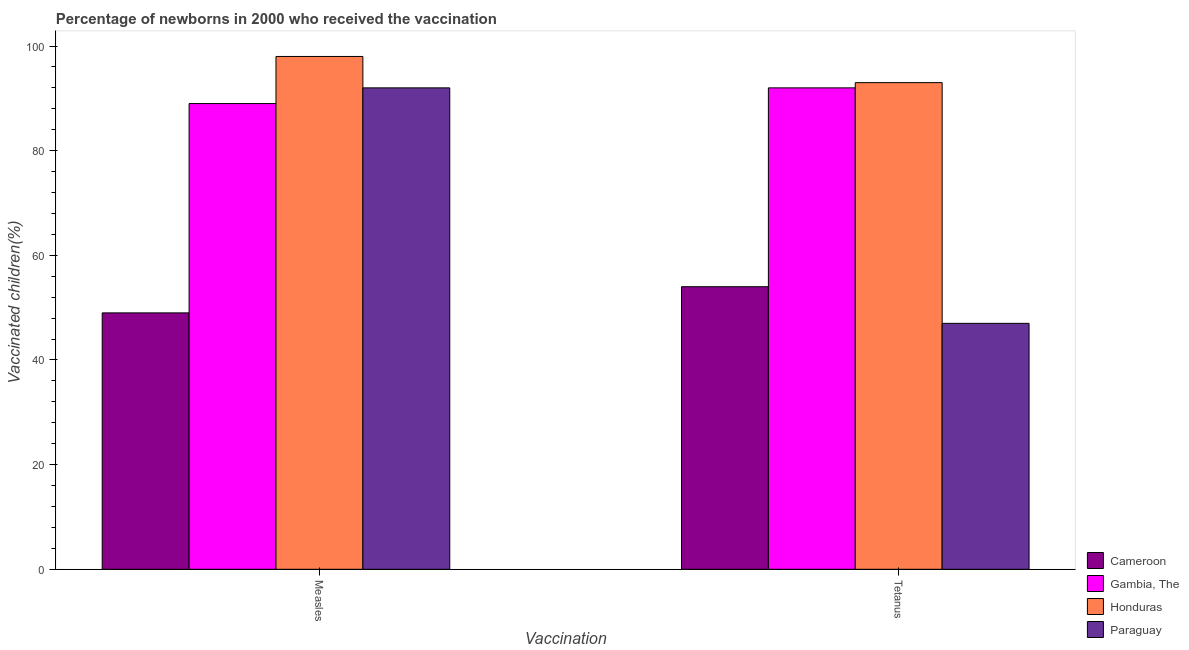How many different coloured bars are there?
Make the answer very short. 4. How many groups of bars are there?
Your response must be concise. 2. Are the number of bars on each tick of the X-axis equal?
Offer a terse response. Yes. How many bars are there on the 2nd tick from the left?
Your response must be concise. 4. How many bars are there on the 2nd tick from the right?
Your answer should be compact. 4. What is the label of the 2nd group of bars from the left?
Keep it short and to the point. Tetanus. What is the percentage of newborns who received vaccination for tetanus in Paraguay?
Offer a very short reply. 47. Across all countries, what is the maximum percentage of newborns who received vaccination for tetanus?
Provide a succinct answer. 93. Across all countries, what is the minimum percentage of newborns who received vaccination for tetanus?
Your answer should be compact. 47. In which country was the percentage of newborns who received vaccination for tetanus maximum?
Your answer should be compact. Honduras. In which country was the percentage of newborns who received vaccination for tetanus minimum?
Make the answer very short. Paraguay. What is the total percentage of newborns who received vaccination for measles in the graph?
Your response must be concise. 328. What is the difference between the percentage of newborns who received vaccination for tetanus in Gambia, The and that in Honduras?
Ensure brevity in your answer.  -1. What is the difference between the percentage of newborns who received vaccination for tetanus in Gambia, The and the percentage of newborns who received vaccination for measles in Paraguay?
Keep it short and to the point. 0. What is the average percentage of newborns who received vaccination for measles per country?
Keep it short and to the point. 82. What is the difference between the percentage of newborns who received vaccination for tetanus and percentage of newborns who received vaccination for measles in Gambia, The?
Make the answer very short. 3. In how many countries, is the percentage of newborns who received vaccination for tetanus greater than 28 %?
Your response must be concise. 4. What is the ratio of the percentage of newborns who received vaccination for tetanus in Honduras to that in Paraguay?
Ensure brevity in your answer.  1.98. Is the percentage of newborns who received vaccination for tetanus in Gambia, The less than that in Cameroon?
Provide a short and direct response. No. What does the 3rd bar from the left in Measles represents?
Your answer should be compact. Honduras. What does the 4th bar from the right in Tetanus represents?
Keep it short and to the point. Cameroon. How many bars are there?
Ensure brevity in your answer.  8. Are all the bars in the graph horizontal?
Offer a very short reply. No. Are the values on the major ticks of Y-axis written in scientific E-notation?
Your response must be concise. No. Does the graph contain any zero values?
Give a very brief answer. No. Does the graph contain grids?
Your response must be concise. No. How many legend labels are there?
Make the answer very short. 4. How are the legend labels stacked?
Provide a short and direct response. Vertical. What is the title of the graph?
Your answer should be compact. Percentage of newborns in 2000 who received the vaccination. Does "Israel" appear as one of the legend labels in the graph?
Keep it short and to the point. No. What is the label or title of the X-axis?
Offer a terse response. Vaccination. What is the label or title of the Y-axis?
Offer a very short reply. Vaccinated children(%)
. What is the Vaccinated children(%)
 of Cameroon in Measles?
Give a very brief answer. 49. What is the Vaccinated children(%)
 of Gambia, The in Measles?
Ensure brevity in your answer.  89. What is the Vaccinated children(%)
 of Honduras in Measles?
Your response must be concise. 98. What is the Vaccinated children(%)
 in Paraguay in Measles?
Ensure brevity in your answer.  92. What is the Vaccinated children(%)
 of Gambia, The in Tetanus?
Give a very brief answer. 92. What is the Vaccinated children(%)
 of Honduras in Tetanus?
Offer a very short reply. 93. What is the Vaccinated children(%)
 of Paraguay in Tetanus?
Give a very brief answer. 47. Across all Vaccination, what is the maximum Vaccinated children(%)
 of Gambia, The?
Keep it short and to the point. 92. Across all Vaccination, what is the maximum Vaccinated children(%)
 of Honduras?
Give a very brief answer. 98. Across all Vaccination, what is the maximum Vaccinated children(%)
 in Paraguay?
Give a very brief answer. 92. Across all Vaccination, what is the minimum Vaccinated children(%)
 of Cameroon?
Ensure brevity in your answer.  49. Across all Vaccination, what is the minimum Vaccinated children(%)
 of Gambia, The?
Provide a succinct answer. 89. Across all Vaccination, what is the minimum Vaccinated children(%)
 of Honduras?
Your response must be concise. 93. What is the total Vaccinated children(%)
 of Cameroon in the graph?
Give a very brief answer. 103. What is the total Vaccinated children(%)
 of Gambia, The in the graph?
Your answer should be very brief. 181. What is the total Vaccinated children(%)
 of Honduras in the graph?
Your answer should be compact. 191. What is the total Vaccinated children(%)
 in Paraguay in the graph?
Your answer should be compact. 139. What is the difference between the Vaccinated children(%)
 of Cameroon in Measles and that in Tetanus?
Ensure brevity in your answer.  -5. What is the difference between the Vaccinated children(%)
 in Gambia, The in Measles and that in Tetanus?
Provide a succinct answer. -3. What is the difference between the Vaccinated children(%)
 in Paraguay in Measles and that in Tetanus?
Ensure brevity in your answer.  45. What is the difference between the Vaccinated children(%)
 in Cameroon in Measles and the Vaccinated children(%)
 in Gambia, The in Tetanus?
Offer a terse response. -43. What is the difference between the Vaccinated children(%)
 of Cameroon in Measles and the Vaccinated children(%)
 of Honduras in Tetanus?
Offer a very short reply. -44. What is the difference between the Vaccinated children(%)
 in Cameroon in Measles and the Vaccinated children(%)
 in Paraguay in Tetanus?
Ensure brevity in your answer.  2. What is the difference between the Vaccinated children(%)
 in Honduras in Measles and the Vaccinated children(%)
 in Paraguay in Tetanus?
Your answer should be very brief. 51. What is the average Vaccinated children(%)
 of Cameroon per Vaccination?
Keep it short and to the point. 51.5. What is the average Vaccinated children(%)
 in Gambia, The per Vaccination?
Your answer should be very brief. 90.5. What is the average Vaccinated children(%)
 in Honduras per Vaccination?
Offer a very short reply. 95.5. What is the average Vaccinated children(%)
 of Paraguay per Vaccination?
Provide a short and direct response. 69.5. What is the difference between the Vaccinated children(%)
 in Cameroon and Vaccinated children(%)
 in Gambia, The in Measles?
Offer a terse response. -40. What is the difference between the Vaccinated children(%)
 of Cameroon and Vaccinated children(%)
 of Honduras in Measles?
Offer a terse response. -49. What is the difference between the Vaccinated children(%)
 of Cameroon and Vaccinated children(%)
 of Paraguay in Measles?
Provide a succinct answer. -43. What is the difference between the Vaccinated children(%)
 of Gambia, The and Vaccinated children(%)
 of Paraguay in Measles?
Give a very brief answer. -3. What is the difference between the Vaccinated children(%)
 in Honduras and Vaccinated children(%)
 in Paraguay in Measles?
Give a very brief answer. 6. What is the difference between the Vaccinated children(%)
 in Cameroon and Vaccinated children(%)
 in Gambia, The in Tetanus?
Your answer should be compact. -38. What is the difference between the Vaccinated children(%)
 in Cameroon and Vaccinated children(%)
 in Honduras in Tetanus?
Ensure brevity in your answer.  -39. What is the difference between the Vaccinated children(%)
 in Gambia, The and Vaccinated children(%)
 in Honduras in Tetanus?
Your answer should be compact. -1. What is the difference between the Vaccinated children(%)
 in Gambia, The and Vaccinated children(%)
 in Paraguay in Tetanus?
Provide a short and direct response. 45. What is the difference between the Vaccinated children(%)
 of Honduras and Vaccinated children(%)
 of Paraguay in Tetanus?
Ensure brevity in your answer.  46. What is the ratio of the Vaccinated children(%)
 in Cameroon in Measles to that in Tetanus?
Provide a short and direct response. 0.91. What is the ratio of the Vaccinated children(%)
 in Gambia, The in Measles to that in Tetanus?
Offer a terse response. 0.97. What is the ratio of the Vaccinated children(%)
 of Honduras in Measles to that in Tetanus?
Make the answer very short. 1.05. What is the ratio of the Vaccinated children(%)
 in Paraguay in Measles to that in Tetanus?
Offer a terse response. 1.96. What is the difference between the highest and the second highest Vaccinated children(%)
 of Paraguay?
Your response must be concise. 45. What is the difference between the highest and the lowest Vaccinated children(%)
 of Cameroon?
Your answer should be compact. 5. What is the difference between the highest and the lowest Vaccinated children(%)
 of Honduras?
Offer a terse response. 5. 